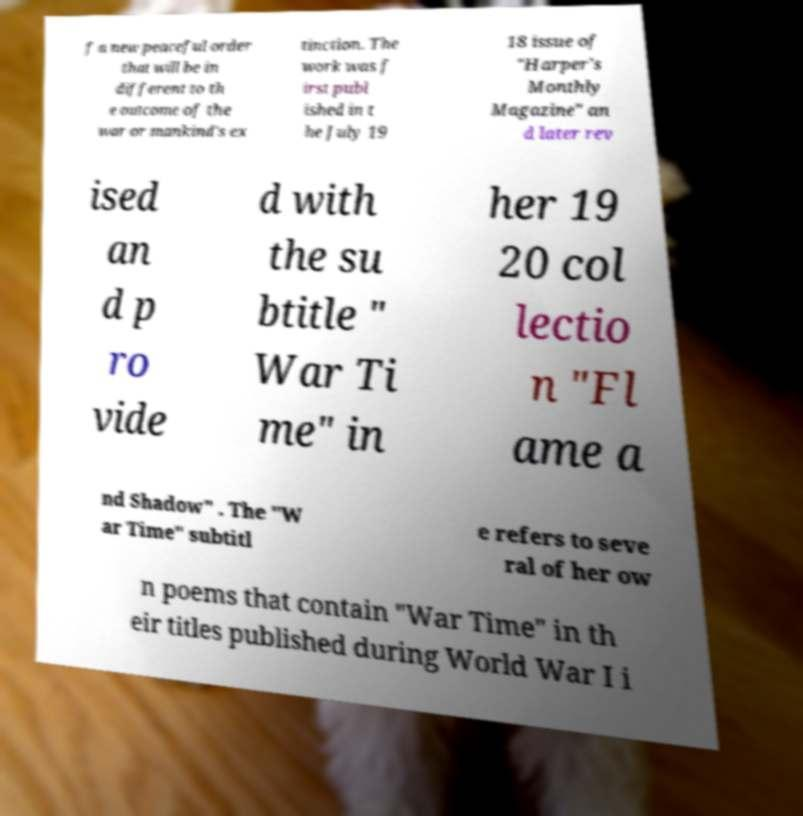Can you read and provide the text displayed in the image?This photo seems to have some interesting text. Can you extract and type it out for me? f a new peaceful order that will be in different to th e outcome of the war or mankind's ex tinction. The work was f irst publ ished in t he July 19 18 issue of "Harper's Monthly Magazine" an d later rev ised an d p ro vide d with the su btitle " War Ti me" in her 19 20 col lectio n "Fl ame a nd Shadow" . The "W ar Time" subtitl e refers to seve ral of her ow n poems that contain "War Time" in th eir titles published during World War I i 